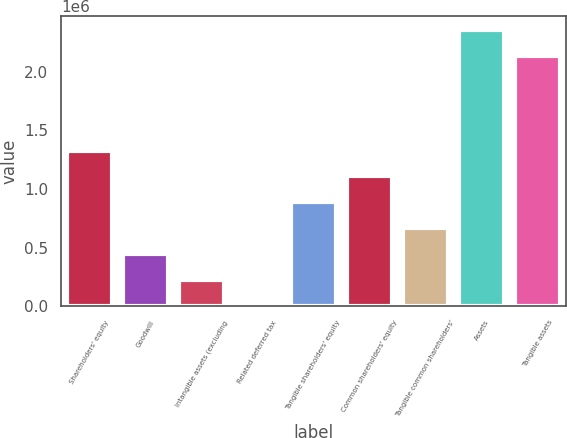Convert chart to OTSL. <chart><loc_0><loc_0><loc_500><loc_500><bar_chart><fcel>Shareholders' equity<fcel>Goodwill<fcel>Intangible assets (excluding<fcel>Related deferred tax<fcel>Tangible shareholders' equity<fcel>Common shareholders' equity<fcel>Tangible common shareholders'<fcel>Assets<fcel>Tangible assets<nl><fcel>1.32698e+06<fcel>443987<fcel>223238<fcel>2490<fcel>885484<fcel>1.10623e+06<fcel>664735<fcel>2.35649e+06<fcel>2.13574e+06<nl></chart> 